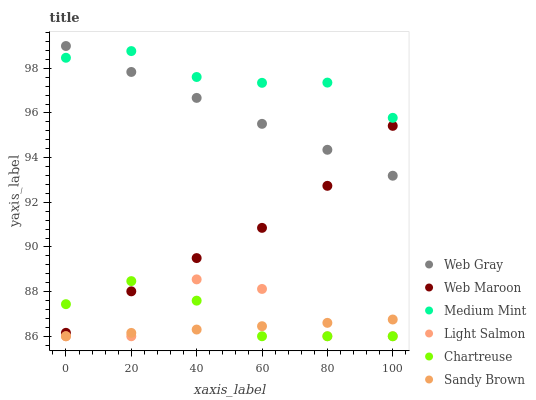Does Sandy Brown have the minimum area under the curve?
Answer yes or no. Yes. Does Medium Mint have the maximum area under the curve?
Answer yes or no. Yes. Does Light Salmon have the minimum area under the curve?
Answer yes or no. No. Does Light Salmon have the maximum area under the curve?
Answer yes or no. No. Is Sandy Brown the smoothest?
Answer yes or no. Yes. Is Light Salmon the roughest?
Answer yes or no. Yes. Is Web Gray the smoothest?
Answer yes or no. No. Is Web Gray the roughest?
Answer yes or no. No. Does Light Salmon have the lowest value?
Answer yes or no. Yes. Does Web Gray have the lowest value?
Answer yes or no. No. Does Web Gray have the highest value?
Answer yes or no. Yes. Does Light Salmon have the highest value?
Answer yes or no. No. Is Light Salmon less than Web Gray?
Answer yes or no. Yes. Is Web Gray greater than Sandy Brown?
Answer yes or no. Yes. Does Web Gray intersect Web Maroon?
Answer yes or no. Yes. Is Web Gray less than Web Maroon?
Answer yes or no. No. Is Web Gray greater than Web Maroon?
Answer yes or no. No. Does Light Salmon intersect Web Gray?
Answer yes or no. No. 